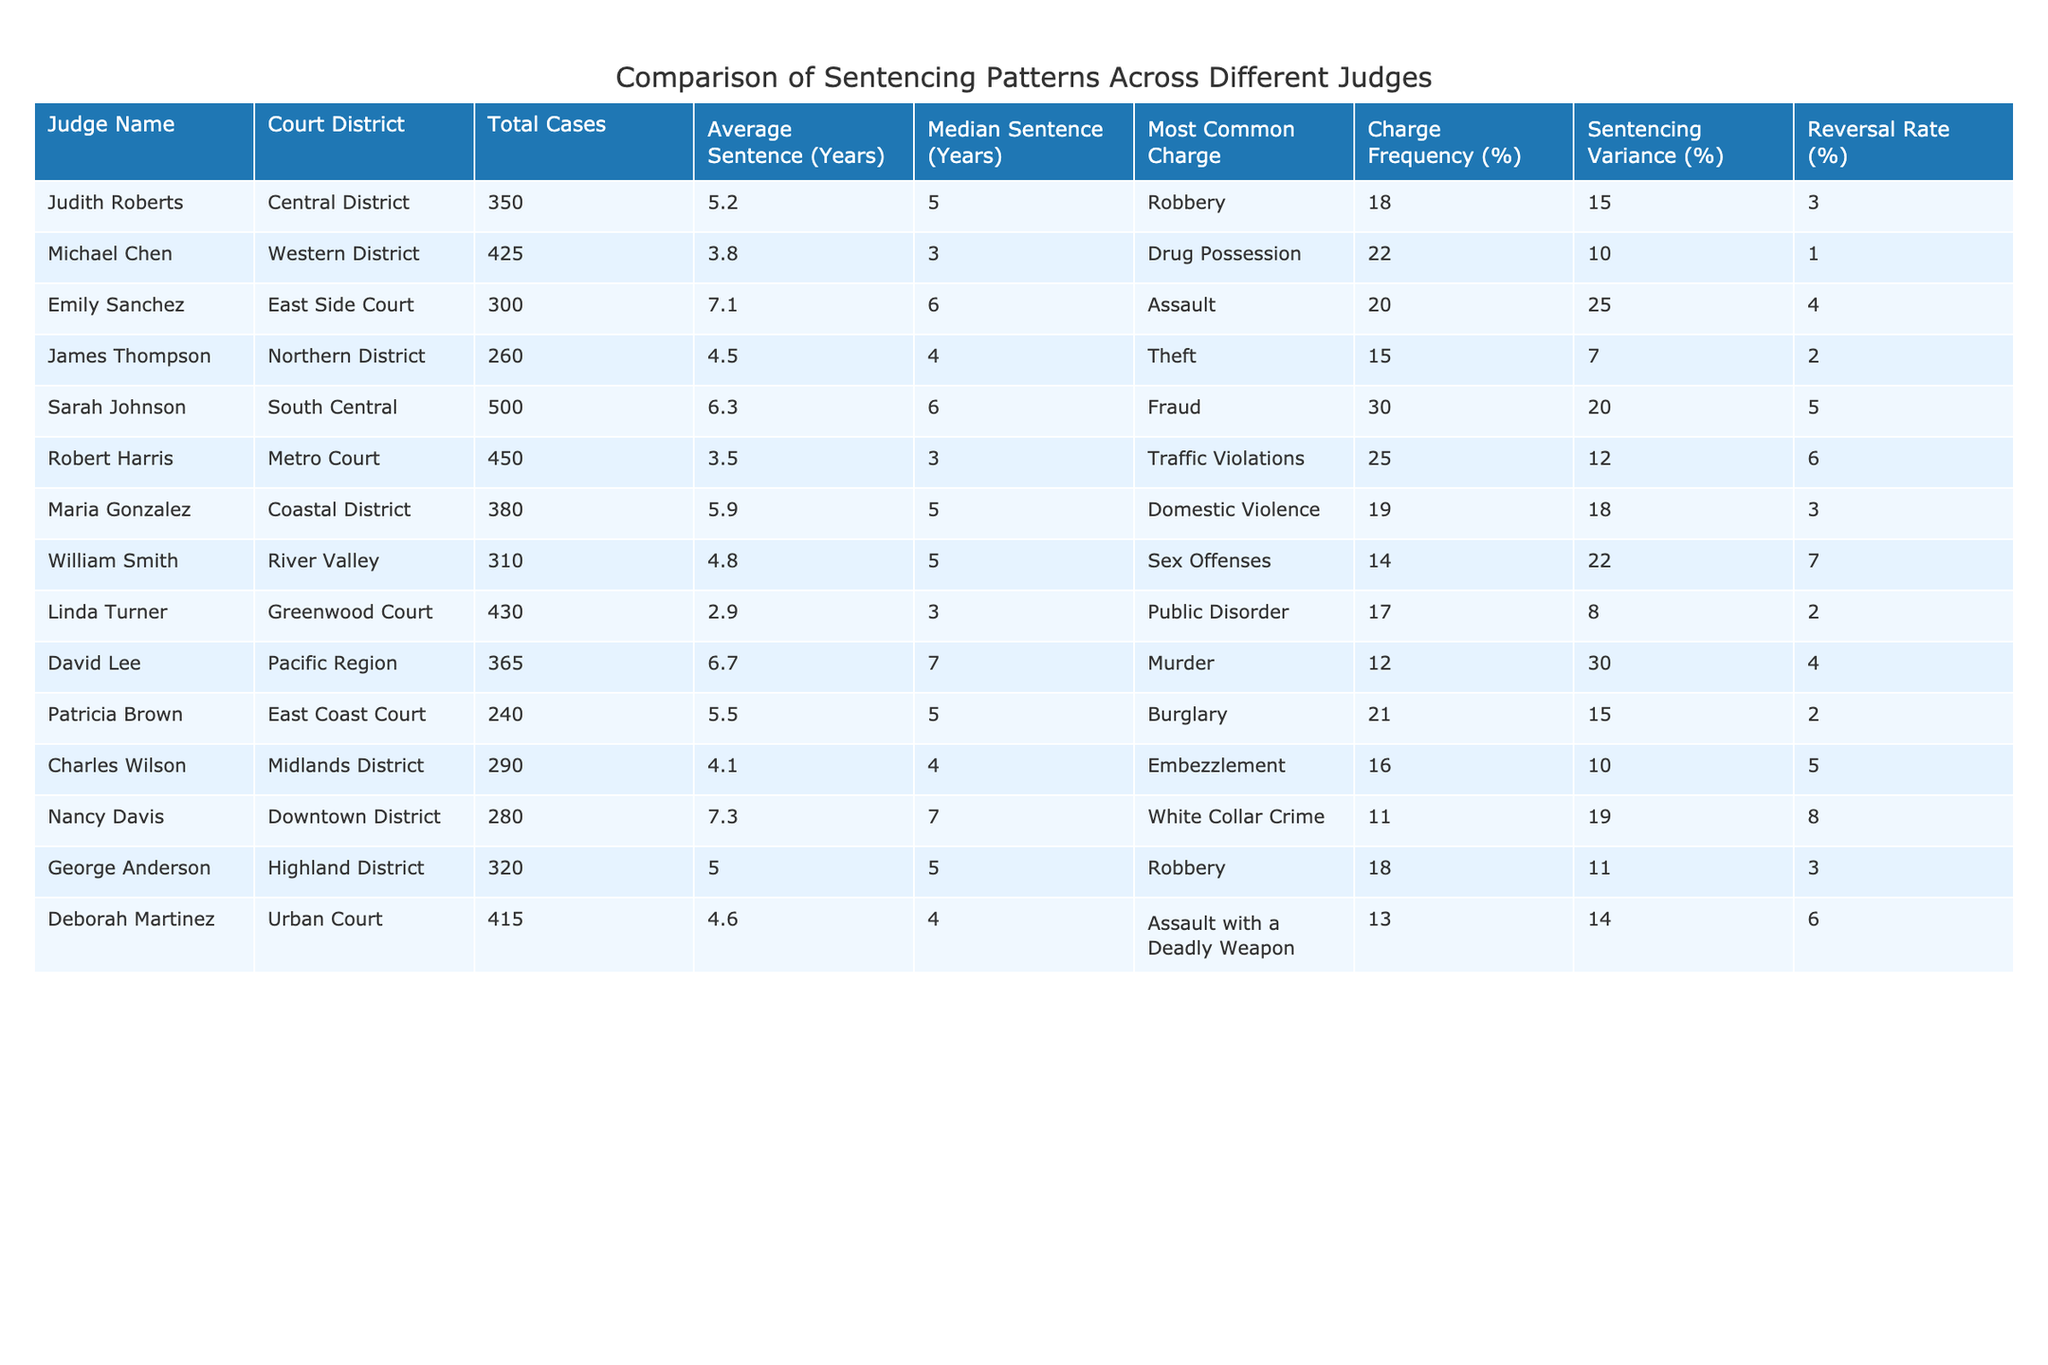What is the name of the judge with the highest average sentence? In the table, I look for the column labeled "Average Sentence (Years)" and find the highest value, which is 7.1 years associated with judge Emily Sanchez.
Answer: Emily Sanchez Which judge has the median sentence of 4 years? I find the column labeled "Median Sentence (Years)" and scan for the value of 4, which corresponds to judges James Thompson and Charles Wilson.
Answer: James Thompson and Charles Wilson What is the total number of cases handled by judges in the Coastal District? I look for the "Court District" column and count the cases for Maria Gonzalez under the Coastal District where the total cases are listed as 380.
Answer: 380 Does Sarah Johnson have a higher average sentence than Robert Harris? I compare the "Average Sentence (Years)" values of Sarah Johnson (6.3) and Robert Harris (3.5). Since 6.3 is greater than 3.5, the answer is yes.
Answer: Yes What is the difference between the highest and lowest command frequency for the most common charges listed? The highest charge frequency is associated with Sarah Johnson at 30%, and the lowest is with Nancy Davis at 11%. The difference is calculated as 30 - 11 = 19%.
Answer: 19% Which judge has the highest reversal rate? I locate the "Reversal Rate (%)" column and identify the maximum value of 8% associated with judge Nancy Davis.
Answer: Nancy Davis Calculate the average total cases across all judges in the table. I sum the total cases (350 + 425 + 300 + 260 + 500 + 450 + 380 + 310 + 430 + 365 + 240 + 290 + 280 + 320 + 415) which equals 5,741. Then, divide by the number of judges (15) to find the average: 5,741 / 15 = 382.73.
Answer: Approximately 382.73 Is the sentencing variance greater for the judge with the most cases? I check the total cases and identify Sarah Johnson with 500 cases, who has a sentencing variance of 20%. I then compare it with others, confirming that this is not the greatest variance since David Lee has a variance of 30%. Thus, the answer is no.
Answer: No Which charge is most common for judges with an average sentence greater than 6 years? I examine the table, identifying judges with an average sentence greater than 6 years: Emily Sanchez (Assault), Sarah Johnson (Fraud), and David Lee (Murder). The common charges here are Assault, Fraud, and Murder. The answer is that there is no single most common charge due to the variety.
Answer: No single most common charge What proportion of judges have a sentencing variance below 15%? I examine the "Sentencing Variance (%)" column and note that only three judges (Michael Chen, James Thompson, and Linda Turner) have a variance below 15%, out of 15 total judges. Thus, the proportion is 3 out of 15, or 20%.
Answer: 20% 